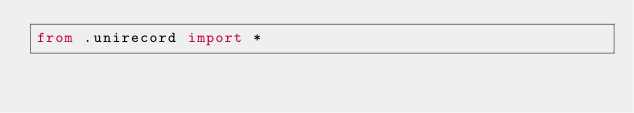Convert code to text. <code><loc_0><loc_0><loc_500><loc_500><_Python_>from .unirecord import *
</code> 